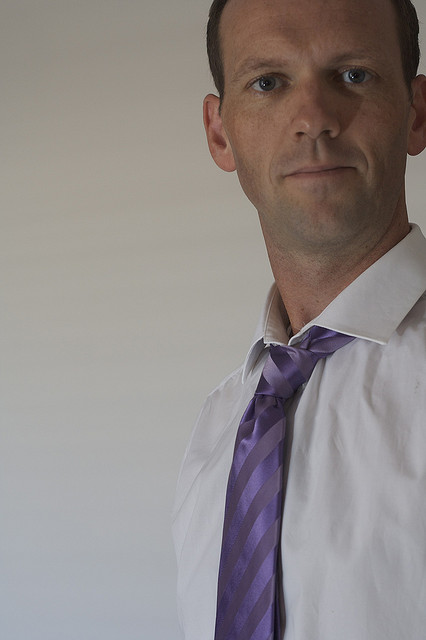<image>Who is the man in the image? It is unknown who the man in the image is. He could be a homeowner, a boss, a businessman, a worker, Andy Roddick, a photographer, or just a business man. Which retail chain has a logo similar to this man's tie? I am not sure which retail chain could have a logo similar to this man's tie. It could possibly be 'Kohl's', 'Sears', 'Target', "McDonald's", or 'Walmart'. However, it is also possible that there is no retail chain logo on the tie. Who is the man in the image? It is unknown who the man is in the image. He can be a homeowner, a businessman, a worker, or someone else. Which retail chain has a logo similar to this man's tie? I don't know which retail chain has a logo similar to this man's tie. It could be any of 'kohl's', 'sears', 'target', "mcdonald's" or 'walmart'. 